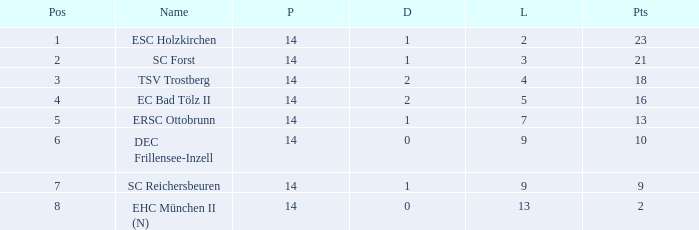Which Lost is the lowest one that has a Name of esc holzkirchen, and Played smaller than 14? None. 